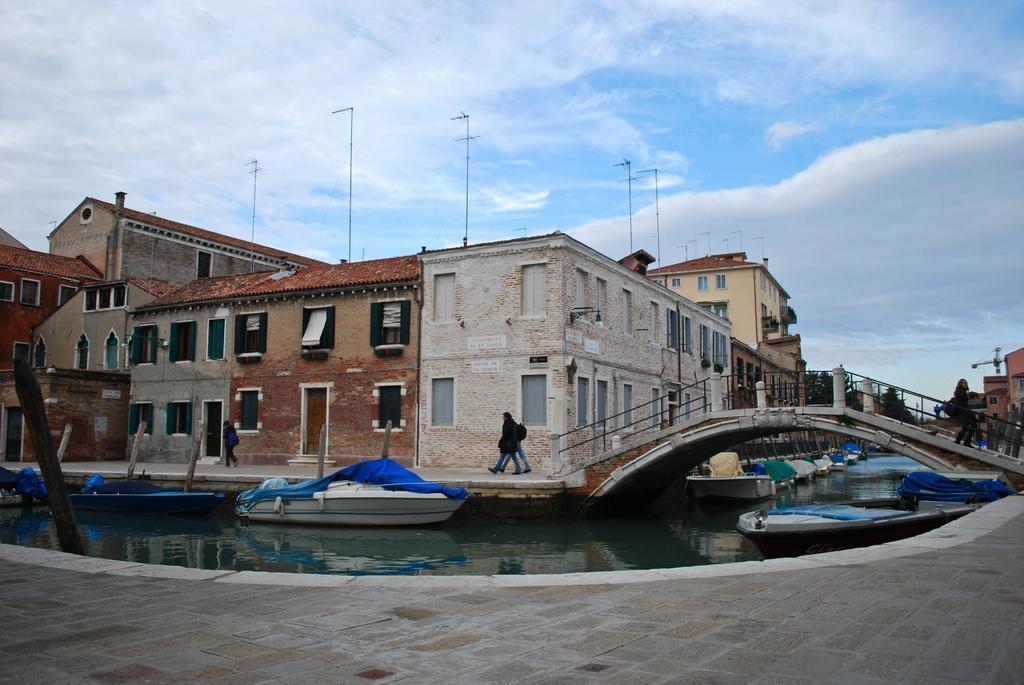In one or two sentences, can you explain what this image depicts? In this picture I can see boats on the water, there is a bridge, group of people standing, there are houses, trees, and in the background there is sky. 